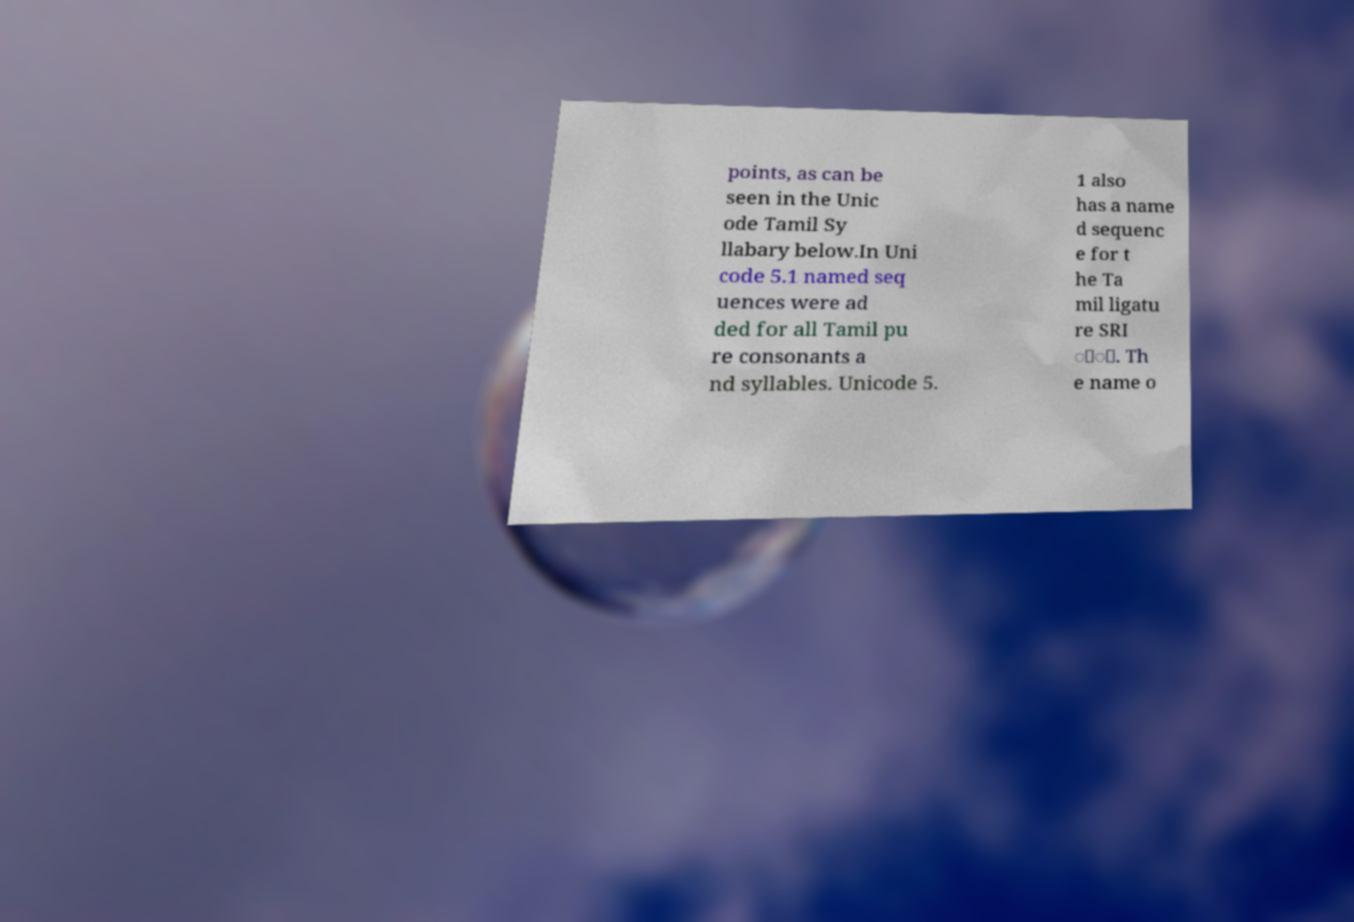Can you read and provide the text displayed in the image?This photo seems to have some interesting text. Can you extract and type it out for me? points, as can be seen in the Unic ode Tamil Sy llabary below.In Uni code 5.1 named seq uences were ad ded for all Tamil pu re consonants a nd syllables. Unicode 5. 1 also has a name d sequenc e for t he Ta mil ligatu re SRI ்ீ. Th e name o 